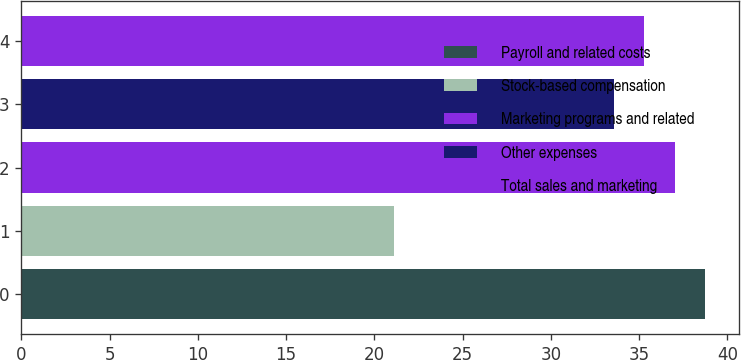Convert chart to OTSL. <chart><loc_0><loc_0><loc_500><loc_500><bar_chart><fcel>Payroll and related costs<fcel>Stock-based compensation<fcel>Marketing programs and related<fcel>Other expenses<fcel>Total sales and marketing<nl><fcel>38.73<fcel>21.1<fcel>37.02<fcel>33.6<fcel>35.31<nl></chart> 